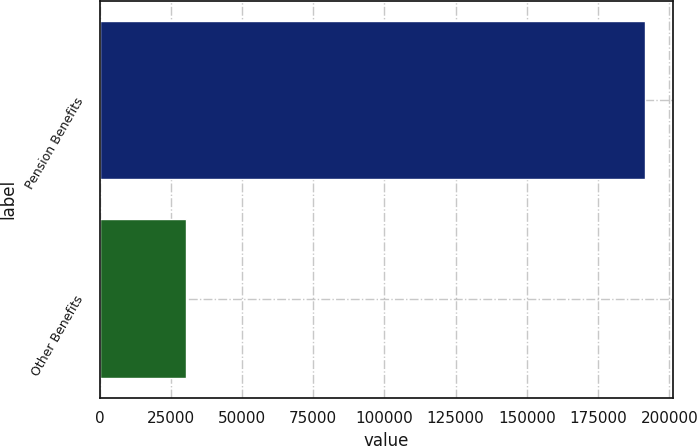Convert chart to OTSL. <chart><loc_0><loc_0><loc_500><loc_500><bar_chart><fcel>Pension Benefits<fcel>Other Benefits<nl><fcel>191593<fcel>30399<nl></chart> 